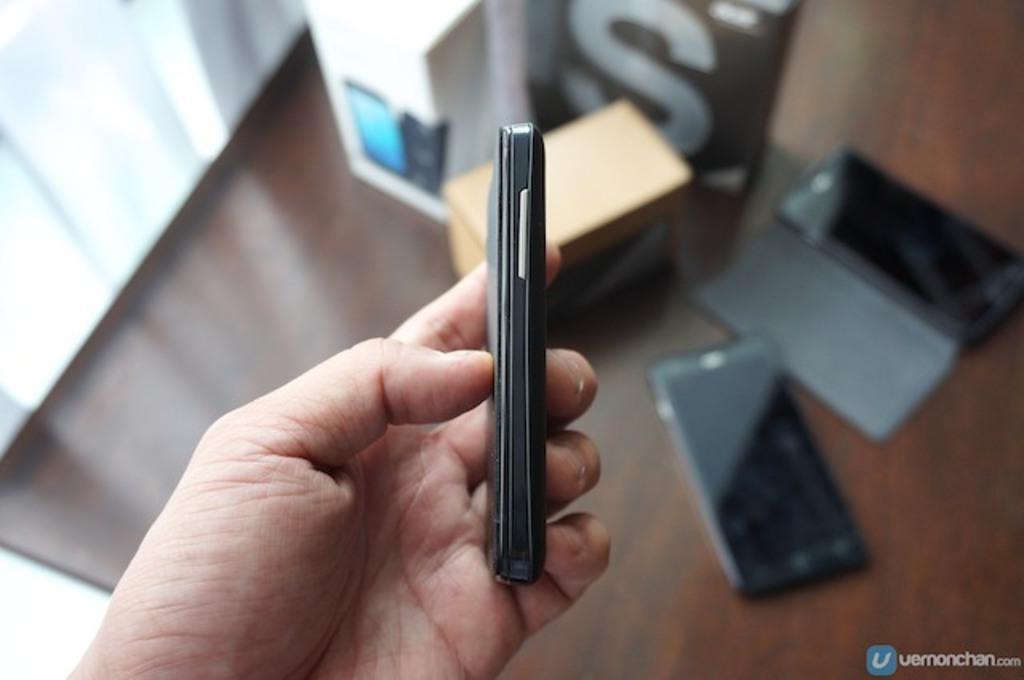Describe this image in one or two sentences. In this image we can see the hand of a person holding a cellphone. On the backside we can see some cell phones and boxes which are placed on the table. 